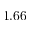<formula> <loc_0><loc_0><loc_500><loc_500>1 . 6 6</formula> 